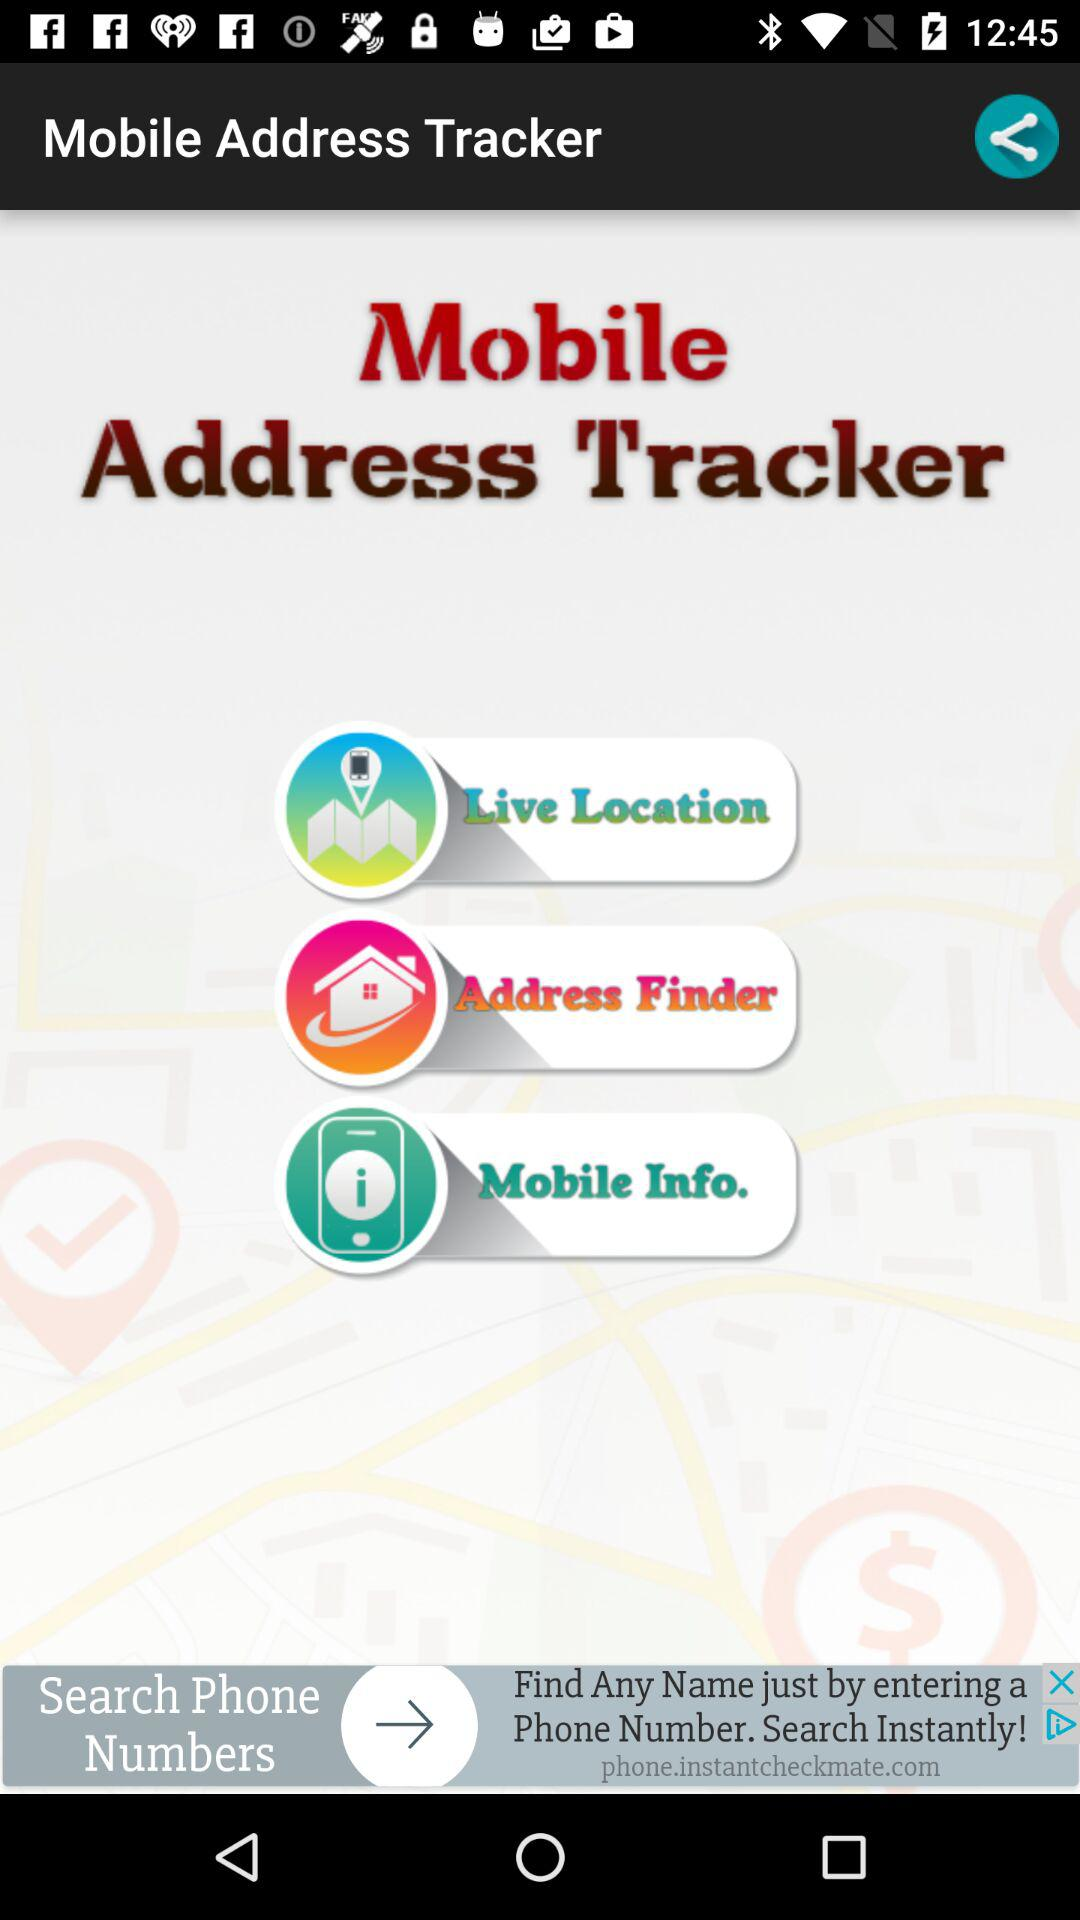What is the name of the application? The name of the application is "Mobile Address Tracker". 